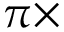<formula> <loc_0><loc_0><loc_500><loc_500>\pi \times</formula> 